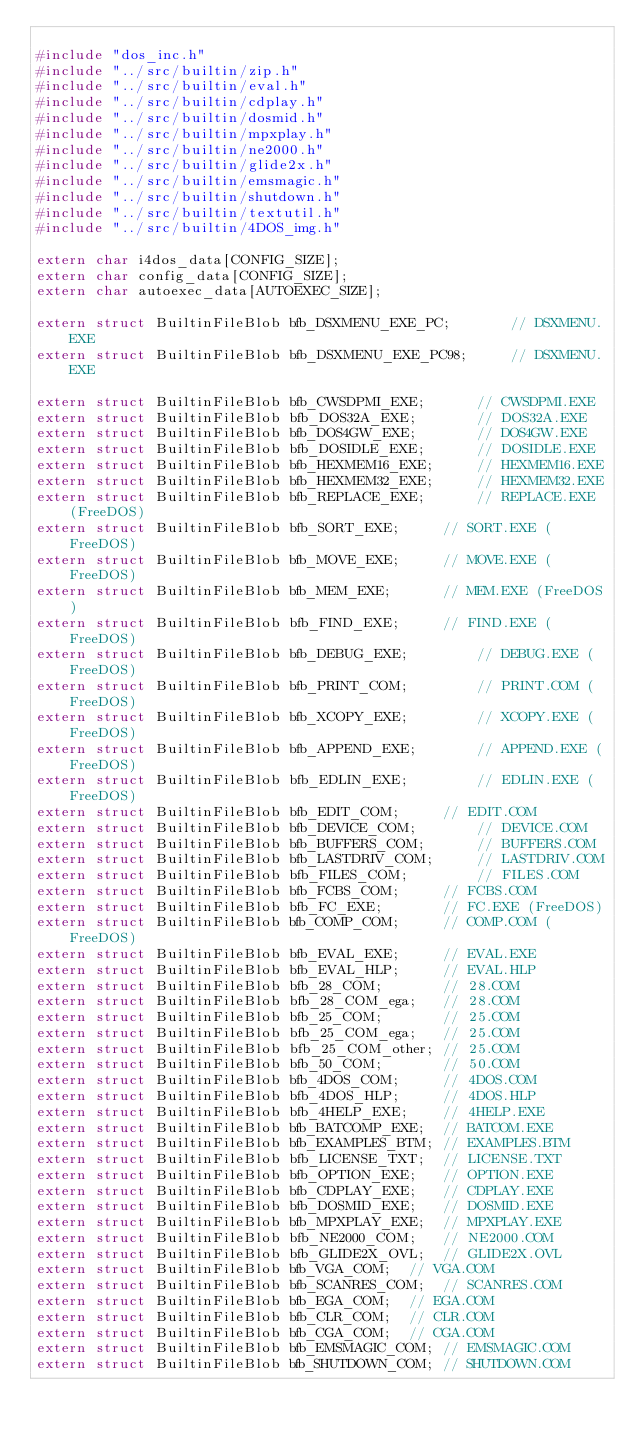<code> <loc_0><loc_0><loc_500><loc_500><_C_>
#include "dos_inc.h"
#include "../src/builtin/zip.h"
#include "../src/builtin/eval.h"
#include "../src/builtin/cdplay.h"
#include "../src/builtin/dosmid.h"
#include "../src/builtin/mpxplay.h"
#include "../src/builtin/ne2000.h"
#include "../src/builtin/glide2x.h"
#include "../src/builtin/emsmagic.h"
#include "../src/builtin/shutdown.h"
#include "../src/builtin/textutil.h"
#include "../src/builtin/4DOS_img.h"

extern char i4dos_data[CONFIG_SIZE];
extern char config_data[CONFIG_SIZE];
extern char autoexec_data[AUTOEXEC_SIZE];

extern struct BuiltinFileBlob bfb_DSXMENU_EXE_PC;		// DSXMENU.EXE
extern struct BuiltinFileBlob bfb_DSXMENU_EXE_PC98;		// DSXMENU.EXE

extern struct BuiltinFileBlob bfb_CWSDPMI_EXE;		// CWSDPMI.EXE
extern struct BuiltinFileBlob bfb_DOS32A_EXE;		// DOS32A.EXE
extern struct BuiltinFileBlob bfb_DOS4GW_EXE;		// DOS4GW.EXE
extern struct BuiltinFileBlob bfb_DOSIDLE_EXE;		// DOSIDLE.EXE
extern struct BuiltinFileBlob bfb_HEXMEM16_EXE;		// HEXMEM16.EXE
extern struct BuiltinFileBlob bfb_HEXMEM32_EXE;		// HEXMEM32.EXE
extern struct BuiltinFileBlob bfb_REPLACE_EXE;		// REPLACE.EXE (FreeDOS)
extern struct BuiltinFileBlob bfb_SORT_EXE;		// SORT.EXE (FreeDOS)
extern struct BuiltinFileBlob bfb_MOVE_EXE;		// MOVE.EXE (FreeDOS)
extern struct BuiltinFileBlob bfb_MEM_EXE;		// MEM.EXE (FreeDOS)
extern struct BuiltinFileBlob bfb_FIND_EXE;		// FIND.EXE (FreeDOS)
extern struct BuiltinFileBlob bfb_DEBUG_EXE;		// DEBUG.EXE (FreeDOS)
extern struct BuiltinFileBlob bfb_PRINT_COM;		// PRINT.COM (FreeDOS)
extern struct BuiltinFileBlob bfb_XCOPY_EXE;		// XCOPY.EXE (FreeDOS)
extern struct BuiltinFileBlob bfb_APPEND_EXE;		// APPEND.EXE (FreeDOS)
extern struct BuiltinFileBlob bfb_EDLIN_EXE;		// EDLIN.EXE (FreeDOS)
extern struct BuiltinFileBlob bfb_EDIT_COM;		// EDIT.COM
extern struct BuiltinFileBlob bfb_DEVICE_COM;		// DEVICE.COM
extern struct BuiltinFileBlob bfb_BUFFERS_COM;		// BUFFERS.COM
extern struct BuiltinFileBlob bfb_LASTDRIV_COM;		// LASTDRIV.COM
extern struct BuiltinFileBlob bfb_FILES_COM;		// FILES.COM
extern struct BuiltinFileBlob bfb_FCBS_COM;		// FCBS.COM
extern struct BuiltinFileBlob bfb_FC_EXE;		// FC.EXE (FreeDOS)
extern struct BuiltinFileBlob bfb_COMP_COM;		// COMP.COM (FreeDOS)
extern struct BuiltinFileBlob bfb_EVAL_EXE;		// EVAL.EXE
extern struct BuiltinFileBlob bfb_EVAL_HLP;		// EVAL.HLP
extern struct BuiltinFileBlob bfb_28_COM;		// 28.COM
extern struct BuiltinFileBlob bfb_28_COM_ega;	// 28.COM
extern struct BuiltinFileBlob bfb_25_COM;		// 25.COM
extern struct BuiltinFileBlob bfb_25_COM_ega;	// 25.COM
extern struct BuiltinFileBlob bfb_25_COM_other;	// 25.COM
extern struct BuiltinFileBlob bfb_50_COM;		// 50.COM
extern struct BuiltinFileBlob bfb_4DOS_COM;		// 4DOS.COM
extern struct BuiltinFileBlob bfb_4DOS_HLP;		// 4DOS.HLP
extern struct BuiltinFileBlob bfb_4HELP_EXE;	// 4HELP.EXE
extern struct BuiltinFileBlob bfb_BATCOMP_EXE;	// BATCOM.EXE
extern struct BuiltinFileBlob bfb_EXAMPLES_BTM;	// EXAMPLES.BTM
extern struct BuiltinFileBlob bfb_LICENSE_TXT;	// LICENSE.TXT
extern struct BuiltinFileBlob bfb_OPTION_EXE;	// OPTION.EXE
extern struct BuiltinFileBlob bfb_CDPLAY_EXE;	// CDPLAY.EXE
extern struct BuiltinFileBlob bfb_DOSMID_EXE;	// DOSMID.EXE
extern struct BuiltinFileBlob bfb_MPXPLAY_EXE;	// MPXPLAY.EXE
extern struct BuiltinFileBlob bfb_NE2000_COM;	// NE2000.COM
extern struct BuiltinFileBlob bfb_GLIDE2X_OVL;	// GLIDE2X.OVL
extern struct BuiltinFileBlob bfb_VGA_COM;	// VGA.COM
extern struct BuiltinFileBlob bfb_SCANRES_COM;	// SCANRES.COM
extern struct BuiltinFileBlob bfb_EGA_COM;	// EGA.COM
extern struct BuiltinFileBlob bfb_CLR_COM;	// CLR.COM
extern struct BuiltinFileBlob bfb_CGA_COM;	// CGA.COM
extern struct BuiltinFileBlob bfb_EMSMAGIC_COM;	// EMSMAGIC.COM
extern struct BuiltinFileBlob bfb_SHUTDOWN_COM;	// SHUTDOWN.COM</code> 